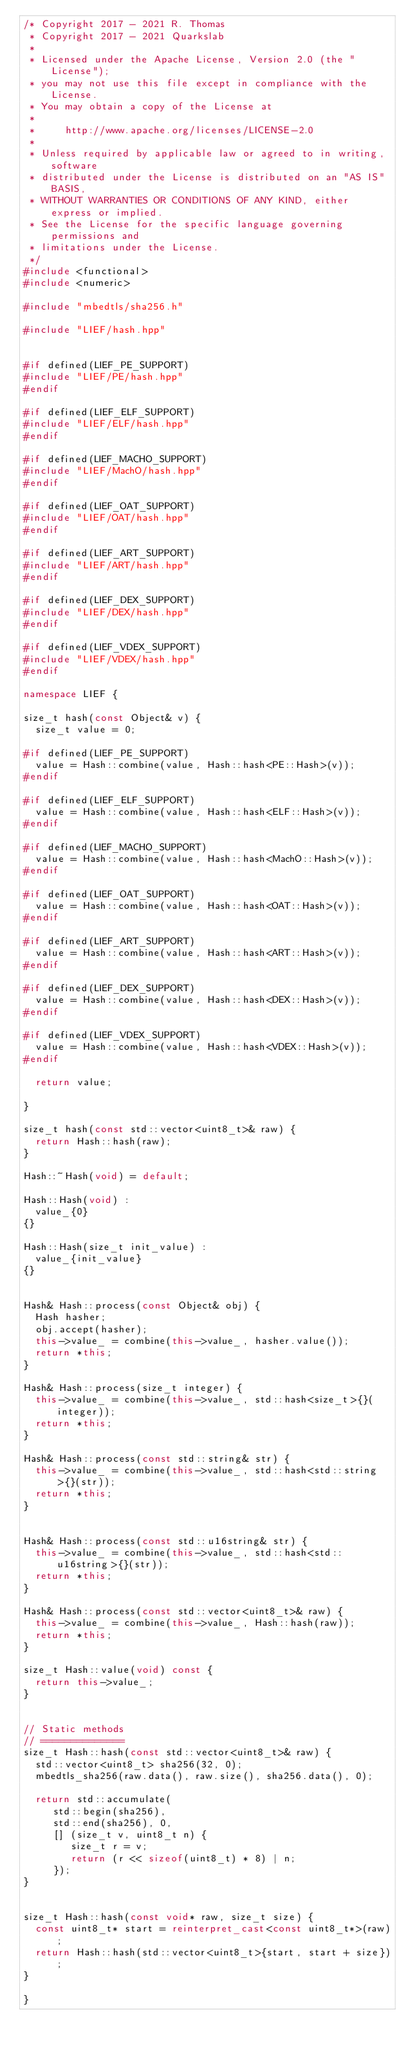<code> <loc_0><loc_0><loc_500><loc_500><_C++_>/* Copyright 2017 - 2021 R. Thomas
 * Copyright 2017 - 2021 Quarkslab
 *
 * Licensed under the Apache License, Version 2.0 (the "License");
 * you may not use this file except in compliance with the License.
 * You may obtain a copy of the License at
 *
 *     http://www.apache.org/licenses/LICENSE-2.0
 *
 * Unless required by applicable law or agreed to in writing, software
 * distributed under the License is distributed on an "AS IS" BASIS,
 * WITHOUT WARRANTIES OR CONDITIONS OF ANY KIND, either express or implied.
 * See the License for the specific language governing permissions and
 * limitations under the License.
 */
#include <functional>
#include <numeric>

#include "mbedtls/sha256.h"

#include "LIEF/hash.hpp"


#if defined(LIEF_PE_SUPPORT)
#include "LIEF/PE/hash.hpp"
#endif

#if defined(LIEF_ELF_SUPPORT)
#include "LIEF/ELF/hash.hpp"
#endif

#if defined(LIEF_MACHO_SUPPORT)
#include "LIEF/MachO/hash.hpp"
#endif

#if defined(LIEF_OAT_SUPPORT)
#include "LIEF/OAT/hash.hpp"
#endif

#if defined(LIEF_ART_SUPPORT)
#include "LIEF/ART/hash.hpp"
#endif

#if defined(LIEF_DEX_SUPPORT)
#include "LIEF/DEX/hash.hpp"
#endif

#if defined(LIEF_VDEX_SUPPORT)
#include "LIEF/VDEX/hash.hpp"
#endif

namespace LIEF {

size_t hash(const Object& v) {
  size_t value = 0;

#if defined(LIEF_PE_SUPPORT)
  value = Hash::combine(value, Hash::hash<PE::Hash>(v));
#endif

#if defined(LIEF_ELF_SUPPORT)
  value = Hash::combine(value, Hash::hash<ELF::Hash>(v));
#endif

#if defined(LIEF_MACHO_SUPPORT)
  value = Hash::combine(value, Hash::hash<MachO::Hash>(v));
#endif

#if defined(LIEF_OAT_SUPPORT)
  value = Hash::combine(value, Hash::hash<OAT::Hash>(v));
#endif

#if defined(LIEF_ART_SUPPORT)
  value = Hash::combine(value, Hash::hash<ART::Hash>(v));
#endif

#if defined(LIEF_DEX_SUPPORT)
  value = Hash::combine(value, Hash::hash<DEX::Hash>(v));
#endif

#if defined(LIEF_VDEX_SUPPORT)
  value = Hash::combine(value, Hash::hash<VDEX::Hash>(v));
#endif

  return value;

}

size_t hash(const std::vector<uint8_t>& raw) {
  return Hash::hash(raw);
}

Hash::~Hash(void) = default;

Hash::Hash(void) :
  value_{0}
{}

Hash::Hash(size_t init_value) :
  value_{init_value}
{}


Hash& Hash::process(const Object& obj) {
  Hash hasher;
  obj.accept(hasher);
  this->value_ = combine(this->value_, hasher.value());
  return *this;
}

Hash& Hash::process(size_t integer) {
  this->value_ = combine(this->value_, std::hash<size_t>{}(integer));
  return *this;
}

Hash& Hash::process(const std::string& str) {
  this->value_ = combine(this->value_, std::hash<std::string>{}(str));
  return *this;
}


Hash& Hash::process(const std::u16string& str) {
  this->value_ = combine(this->value_, std::hash<std::u16string>{}(str));
  return *this;
}

Hash& Hash::process(const std::vector<uint8_t>& raw) {
  this->value_ = combine(this->value_, Hash::hash(raw));
  return *this;
}

size_t Hash::value(void) const {
  return this->value_;
}


// Static methods
// ==============
size_t Hash::hash(const std::vector<uint8_t>& raw) {
  std::vector<uint8_t> sha256(32, 0);
  mbedtls_sha256(raw.data(), raw.size(), sha256.data(), 0);

  return std::accumulate(
     std::begin(sha256),
     std::end(sha256), 0,
     [] (size_t v, uint8_t n) {
        size_t r = v;
        return (r << sizeof(uint8_t) * 8) | n;
     });
}


size_t Hash::hash(const void* raw, size_t size) {
  const uint8_t* start = reinterpret_cast<const uint8_t*>(raw);
  return Hash::hash(std::vector<uint8_t>{start, start + size});
}

}
</code> 